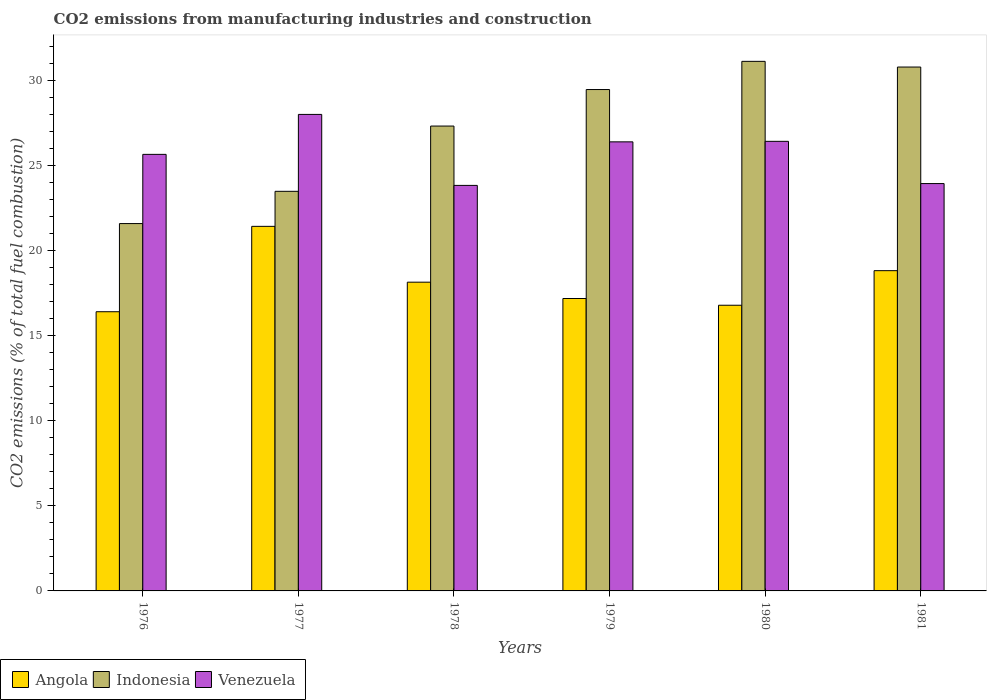How many different coloured bars are there?
Keep it short and to the point. 3. How many groups of bars are there?
Your answer should be compact. 6. Are the number of bars on each tick of the X-axis equal?
Your answer should be compact. Yes. What is the amount of CO2 emitted in Angola in 1980?
Provide a short and direct response. 16.79. Across all years, what is the maximum amount of CO2 emitted in Venezuela?
Your answer should be compact. 28.01. Across all years, what is the minimum amount of CO2 emitted in Venezuela?
Keep it short and to the point. 23.84. In which year was the amount of CO2 emitted in Indonesia maximum?
Ensure brevity in your answer.  1980. In which year was the amount of CO2 emitted in Indonesia minimum?
Ensure brevity in your answer.  1976. What is the total amount of CO2 emitted in Angola in the graph?
Ensure brevity in your answer.  108.79. What is the difference between the amount of CO2 emitted in Angola in 1977 and that in 1979?
Keep it short and to the point. 4.24. What is the difference between the amount of CO2 emitted in Angola in 1977 and the amount of CO2 emitted in Indonesia in 1980?
Provide a succinct answer. -9.7. What is the average amount of CO2 emitted in Angola per year?
Your answer should be compact. 18.13. In the year 1980, what is the difference between the amount of CO2 emitted in Indonesia and amount of CO2 emitted in Venezuela?
Ensure brevity in your answer.  4.7. What is the ratio of the amount of CO2 emitted in Angola in 1977 to that in 1981?
Your answer should be compact. 1.14. Is the amount of CO2 emitted in Venezuela in 1976 less than that in 1978?
Offer a very short reply. No. What is the difference between the highest and the second highest amount of CO2 emitted in Venezuela?
Keep it short and to the point. 1.58. What is the difference between the highest and the lowest amount of CO2 emitted in Venezuela?
Ensure brevity in your answer.  4.17. In how many years, is the amount of CO2 emitted in Venezuela greater than the average amount of CO2 emitted in Venezuela taken over all years?
Your answer should be compact. 3. What does the 3rd bar from the right in 1981 represents?
Your response must be concise. Angola. Are all the bars in the graph horizontal?
Your answer should be very brief. No. What is the difference between two consecutive major ticks on the Y-axis?
Keep it short and to the point. 5. Are the values on the major ticks of Y-axis written in scientific E-notation?
Your answer should be very brief. No. Does the graph contain grids?
Ensure brevity in your answer.  No. Where does the legend appear in the graph?
Ensure brevity in your answer.  Bottom left. What is the title of the graph?
Give a very brief answer. CO2 emissions from manufacturing industries and construction. What is the label or title of the Y-axis?
Keep it short and to the point. CO2 emissions (% of total fuel combustion). What is the CO2 emissions (% of total fuel combustion) in Angola in 1976?
Make the answer very short. 16.41. What is the CO2 emissions (% of total fuel combustion) of Indonesia in 1976?
Your answer should be very brief. 21.59. What is the CO2 emissions (% of total fuel combustion) of Venezuela in 1976?
Offer a terse response. 25.66. What is the CO2 emissions (% of total fuel combustion) in Angola in 1977?
Provide a succinct answer. 21.43. What is the CO2 emissions (% of total fuel combustion) of Indonesia in 1977?
Make the answer very short. 23.49. What is the CO2 emissions (% of total fuel combustion) in Venezuela in 1977?
Give a very brief answer. 28.01. What is the CO2 emissions (% of total fuel combustion) of Angola in 1978?
Offer a very short reply. 18.15. What is the CO2 emissions (% of total fuel combustion) of Indonesia in 1978?
Ensure brevity in your answer.  27.32. What is the CO2 emissions (% of total fuel combustion) in Venezuela in 1978?
Your answer should be very brief. 23.84. What is the CO2 emissions (% of total fuel combustion) in Angola in 1979?
Your answer should be very brief. 17.19. What is the CO2 emissions (% of total fuel combustion) of Indonesia in 1979?
Give a very brief answer. 29.47. What is the CO2 emissions (% of total fuel combustion) of Venezuela in 1979?
Give a very brief answer. 26.4. What is the CO2 emissions (% of total fuel combustion) of Angola in 1980?
Your answer should be very brief. 16.79. What is the CO2 emissions (% of total fuel combustion) in Indonesia in 1980?
Provide a short and direct response. 31.13. What is the CO2 emissions (% of total fuel combustion) of Venezuela in 1980?
Your response must be concise. 26.43. What is the CO2 emissions (% of total fuel combustion) of Angola in 1981?
Your answer should be compact. 18.82. What is the CO2 emissions (% of total fuel combustion) of Indonesia in 1981?
Ensure brevity in your answer.  30.79. What is the CO2 emissions (% of total fuel combustion) in Venezuela in 1981?
Your response must be concise. 23.94. Across all years, what is the maximum CO2 emissions (% of total fuel combustion) in Angola?
Give a very brief answer. 21.43. Across all years, what is the maximum CO2 emissions (% of total fuel combustion) in Indonesia?
Ensure brevity in your answer.  31.13. Across all years, what is the maximum CO2 emissions (% of total fuel combustion) of Venezuela?
Your answer should be very brief. 28.01. Across all years, what is the minimum CO2 emissions (% of total fuel combustion) of Angola?
Keep it short and to the point. 16.41. Across all years, what is the minimum CO2 emissions (% of total fuel combustion) in Indonesia?
Offer a terse response. 21.59. Across all years, what is the minimum CO2 emissions (% of total fuel combustion) of Venezuela?
Offer a very short reply. 23.84. What is the total CO2 emissions (% of total fuel combustion) of Angola in the graph?
Provide a short and direct response. 108.79. What is the total CO2 emissions (% of total fuel combustion) in Indonesia in the graph?
Your answer should be compact. 163.79. What is the total CO2 emissions (% of total fuel combustion) in Venezuela in the graph?
Keep it short and to the point. 154.27. What is the difference between the CO2 emissions (% of total fuel combustion) in Angola in 1976 and that in 1977?
Provide a succinct answer. -5.02. What is the difference between the CO2 emissions (% of total fuel combustion) in Indonesia in 1976 and that in 1977?
Provide a succinct answer. -1.9. What is the difference between the CO2 emissions (% of total fuel combustion) of Venezuela in 1976 and that in 1977?
Your answer should be compact. -2.35. What is the difference between the CO2 emissions (% of total fuel combustion) of Angola in 1976 and that in 1978?
Provide a succinct answer. -1.74. What is the difference between the CO2 emissions (% of total fuel combustion) in Indonesia in 1976 and that in 1978?
Provide a short and direct response. -5.73. What is the difference between the CO2 emissions (% of total fuel combustion) in Venezuela in 1976 and that in 1978?
Provide a short and direct response. 1.82. What is the difference between the CO2 emissions (% of total fuel combustion) in Angola in 1976 and that in 1979?
Provide a short and direct response. -0.78. What is the difference between the CO2 emissions (% of total fuel combustion) of Indonesia in 1976 and that in 1979?
Keep it short and to the point. -7.88. What is the difference between the CO2 emissions (% of total fuel combustion) of Venezuela in 1976 and that in 1979?
Your response must be concise. -0.74. What is the difference between the CO2 emissions (% of total fuel combustion) in Angola in 1976 and that in 1980?
Your response must be concise. -0.38. What is the difference between the CO2 emissions (% of total fuel combustion) in Indonesia in 1976 and that in 1980?
Give a very brief answer. -9.53. What is the difference between the CO2 emissions (% of total fuel combustion) in Venezuela in 1976 and that in 1980?
Keep it short and to the point. -0.77. What is the difference between the CO2 emissions (% of total fuel combustion) in Angola in 1976 and that in 1981?
Give a very brief answer. -2.41. What is the difference between the CO2 emissions (% of total fuel combustion) in Indonesia in 1976 and that in 1981?
Your response must be concise. -9.2. What is the difference between the CO2 emissions (% of total fuel combustion) in Venezuela in 1976 and that in 1981?
Keep it short and to the point. 1.72. What is the difference between the CO2 emissions (% of total fuel combustion) of Angola in 1977 and that in 1978?
Your answer should be very brief. 3.28. What is the difference between the CO2 emissions (% of total fuel combustion) in Indonesia in 1977 and that in 1978?
Offer a terse response. -3.84. What is the difference between the CO2 emissions (% of total fuel combustion) in Venezuela in 1977 and that in 1978?
Offer a terse response. 4.17. What is the difference between the CO2 emissions (% of total fuel combustion) of Angola in 1977 and that in 1979?
Your response must be concise. 4.24. What is the difference between the CO2 emissions (% of total fuel combustion) in Indonesia in 1977 and that in 1979?
Keep it short and to the point. -5.98. What is the difference between the CO2 emissions (% of total fuel combustion) in Venezuela in 1977 and that in 1979?
Offer a terse response. 1.61. What is the difference between the CO2 emissions (% of total fuel combustion) of Angola in 1977 and that in 1980?
Ensure brevity in your answer.  4.64. What is the difference between the CO2 emissions (% of total fuel combustion) in Indonesia in 1977 and that in 1980?
Provide a succinct answer. -7.64. What is the difference between the CO2 emissions (% of total fuel combustion) of Venezuela in 1977 and that in 1980?
Provide a succinct answer. 1.58. What is the difference between the CO2 emissions (% of total fuel combustion) in Angola in 1977 and that in 1981?
Your response must be concise. 2.6. What is the difference between the CO2 emissions (% of total fuel combustion) of Indonesia in 1977 and that in 1981?
Provide a short and direct response. -7.3. What is the difference between the CO2 emissions (% of total fuel combustion) in Venezuela in 1977 and that in 1981?
Provide a short and direct response. 4.06. What is the difference between the CO2 emissions (% of total fuel combustion) in Angola in 1978 and that in 1979?
Give a very brief answer. 0.96. What is the difference between the CO2 emissions (% of total fuel combustion) of Indonesia in 1978 and that in 1979?
Offer a very short reply. -2.15. What is the difference between the CO2 emissions (% of total fuel combustion) of Venezuela in 1978 and that in 1979?
Make the answer very short. -2.56. What is the difference between the CO2 emissions (% of total fuel combustion) of Angola in 1978 and that in 1980?
Ensure brevity in your answer.  1.36. What is the difference between the CO2 emissions (% of total fuel combustion) of Indonesia in 1978 and that in 1980?
Keep it short and to the point. -3.8. What is the difference between the CO2 emissions (% of total fuel combustion) in Venezuela in 1978 and that in 1980?
Keep it short and to the point. -2.59. What is the difference between the CO2 emissions (% of total fuel combustion) of Angola in 1978 and that in 1981?
Ensure brevity in your answer.  -0.68. What is the difference between the CO2 emissions (% of total fuel combustion) in Indonesia in 1978 and that in 1981?
Your answer should be very brief. -3.47. What is the difference between the CO2 emissions (% of total fuel combustion) in Venezuela in 1978 and that in 1981?
Keep it short and to the point. -0.11. What is the difference between the CO2 emissions (% of total fuel combustion) in Angola in 1979 and that in 1980?
Provide a short and direct response. 0.4. What is the difference between the CO2 emissions (% of total fuel combustion) of Indonesia in 1979 and that in 1980?
Make the answer very short. -1.66. What is the difference between the CO2 emissions (% of total fuel combustion) of Venezuela in 1979 and that in 1980?
Offer a terse response. -0.03. What is the difference between the CO2 emissions (% of total fuel combustion) in Angola in 1979 and that in 1981?
Offer a very short reply. -1.64. What is the difference between the CO2 emissions (% of total fuel combustion) in Indonesia in 1979 and that in 1981?
Your response must be concise. -1.32. What is the difference between the CO2 emissions (% of total fuel combustion) in Venezuela in 1979 and that in 1981?
Your response must be concise. 2.45. What is the difference between the CO2 emissions (% of total fuel combustion) of Angola in 1980 and that in 1981?
Your answer should be very brief. -2.03. What is the difference between the CO2 emissions (% of total fuel combustion) in Indonesia in 1980 and that in 1981?
Keep it short and to the point. 0.33. What is the difference between the CO2 emissions (% of total fuel combustion) of Venezuela in 1980 and that in 1981?
Offer a very short reply. 2.48. What is the difference between the CO2 emissions (% of total fuel combustion) in Angola in 1976 and the CO2 emissions (% of total fuel combustion) in Indonesia in 1977?
Ensure brevity in your answer.  -7.08. What is the difference between the CO2 emissions (% of total fuel combustion) in Angola in 1976 and the CO2 emissions (% of total fuel combustion) in Venezuela in 1977?
Ensure brevity in your answer.  -11.6. What is the difference between the CO2 emissions (% of total fuel combustion) of Indonesia in 1976 and the CO2 emissions (% of total fuel combustion) of Venezuela in 1977?
Provide a short and direct response. -6.42. What is the difference between the CO2 emissions (% of total fuel combustion) in Angola in 1976 and the CO2 emissions (% of total fuel combustion) in Indonesia in 1978?
Make the answer very short. -10.91. What is the difference between the CO2 emissions (% of total fuel combustion) of Angola in 1976 and the CO2 emissions (% of total fuel combustion) of Venezuela in 1978?
Offer a terse response. -7.43. What is the difference between the CO2 emissions (% of total fuel combustion) in Indonesia in 1976 and the CO2 emissions (% of total fuel combustion) in Venezuela in 1978?
Your response must be concise. -2.24. What is the difference between the CO2 emissions (% of total fuel combustion) in Angola in 1976 and the CO2 emissions (% of total fuel combustion) in Indonesia in 1979?
Make the answer very short. -13.06. What is the difference between the CO2 emissions (% of total fuel combustion) in Angola in 1976 and the CO2 emissions (% of total fuel combustion) in Venezuela in 1979?
Offer a very short reply. -9.99. What is the difference between the CO2 emissions (% of total fuel combustion) in Indonesia in 1976 and the CO2 emissions (% of total fuel combustion) in Venezuela in 1979?
Your response must be concise. -4.8. What is the difference between the CO2 emissions (% of total fuel combustion) of Angola in 1976 and the CO2 emissions (% of total fuel combustion) of Indonesia in 1980?
Offer a very short reply. -14.72. What is the difference between the CO2 emissions (% of total fuel combustion) in Angola in 1976 and the CO2 emissions (% of total fuel combustion) in Venezuela in 1980?
Your answer should be very brief. -10.02. What is the difference between the CO2 emissions (% of total fuel combustion) of Indonesia in 1976 and the CO2 emissions (% of total fuel combustion) of Venezuela in 1980?
Offer a terse response. -4.83. What is the difference between the CO2 emissions (% of total fuel combustion) of Angola in 1976 and the CO2 emissions (% of total fuel combustion) of Indonesia in 1981?
Provide a succinct answer. -14.38. What is the difference between the CO2 emissions (% of total fuel combustion) in Angola in 1976 and the CO2 emissions (% of total fuel combustion) in Venezuela in 1981?
Provide a short and direct response. -7.53. What is the difference between the CO2 emissions (% of total fuel combustion) in Indonesia in 1976 and the CO2 emissions (% of total fuel combustion) in Venezuela in 1981?
Provide a short and direct response. -2.35. What is the difference between the CO2 emissions (% of total fuel combustion) in Angola in 1977 and the CO2 emissions (% of total fuel combustion) in Indonesia in 1978?
Provide a short and direct response. -5.89. What is the difference between the CO2 emissions (% of total fuel combustion) of Angola in 1977 and the CO2 emissions (% of total fuel combustion) of Venezuela in 1978?
Provide a short and direct response. -2.41. What is the difference between the CO2 emissions (% of total fuel combustion) in Indonesia in 1977 and the CO2 emissions (% of total fuel combustion) in Venezuela in 1978?
Offer a terse response. -0.35. What is the difference between the CO2 emissions (% of total fuel combustion) of Angola in 1977 and the CO2 emissions (% of total fuel combustion) of Indonesia in 1979?
Offer a terse response. -8.04. What is the difference between the CO2 emissions (% of total fuel combustion) in Angola in 1977 and the CO2 emissions (% of total fuel combustion) in Venezuela in 1979?
Offer a terse response. -4.97. What is the difference between the CO2 emissions (% of total fuel combustion) of Indonesia in 1977 and the CO2 emissions (% of total fuel combustion) of Venezuela in 1979?
Your response must be concise. -2.91. What is the difference between the CO2 emissions (% of total fuel combustion) of Angola in 1977 and the CO2 emissions (% of total fuel combustion) of Indonesia in 1980?
Provide a succinct answer. -9.7. What is the difference between the CO2 emissions (% of total fuel combustion) in Angola in 1977 and the CO2 emissions (% of total fuel combustion) in Venezuela in 1980?
Ensure brevity in your answer.  -5. What is the difference between the CO2 emissions (% of total fuel combustion) of Indonesia in 1977 and the CO2 emissions (% of total fuel combustion) of Venezuela in 1980?
Offer a terse response. -2.94. What is the difference between the CO2 emissions (% of total fuel combustion) in Angola in 1977 and the CO2 emissions (% of total fuel combustion) in Indonesia in 1981?
Provide a short and direct response. -9.36. What is the difference between the CO2 emissions (% of total fuel combustion) in Angola in 1977 and the CO2 emissions (% of total fuel combustion) in Venezuela in 1981?
Ensure brevity in your answer.  -2.51. What is the difference between the CO2 emissions (% of total fuel combustion) in Indonesia in 1977 and the CO2 emissions (% of total fuel combustion) in Venezuela in 1981?
Give a very brief answer. -0.46. What is the difference between the CO2 emissions (% of total fuel combustion) in Angola in 1978 and the CO2 emissions (% of total fuel combustion) in Indonesia in 1979?
Your answer should be compact. -11.32. What is the difference between the CO2 emissions (% of total fuel combustion) of Angola in 1978 and the CO2 emissions (% of total fuel combustion) of Venezuela in 1979?
Make the answer very short. -8.25. What is the difference between the CO2 emissions (% of total fuel combustion) of Indonesia in 1978 and the CO2 emissions (% of total fuel combustion) of Venezuela in 1979?
Your response must be concise. 0.93. What is the difference between the CO2 emissions (% of total fuel combustion) in Angola in 1978 and the CO2 emissions (% of total fuel combustion) in Indonesia in 1980?
Your response must be concise. -12.98. What is the difference between the CO2 emissions (% of total fuel combustion) in Angola in 1978 and the CO2 emissions (% of total fuel combustion) in Venezuela in 1980?
Ensure brevity in your answer.  -8.28. What is the difference between the CO2 emissions (% of total fuel combustion) in Indonesia in 1978 and the CO2 emissions (% of total fuel combustion) in Venezuela in 1980?
Offer a terse response. 0.9. What is the difference between the CO2 emissions (% of total fuel combustion) in Angola in 1978 and the CO2 emissions (% of total fuel combustion) in Indonesia in 1981?
Make the answer very short. -12.65. What is the difference between the CO2 emissions (% of total fuel combustion) of Angola in 1978 and the CO2 emissions (% of total fuel combustion) of Venezuela in 1981?
Ensure brevity in your answer.  -5.8. What is the difference between the CO2 emissions (% of total fuel combustion) of Indonesia in 1978 and the CO2 emissions (% of total fuel combustion) of Venezuela in 1981?
Your response must be concise. 3.38. What is the difference between the CO2 emissions (% of total fuel combustion) in Angola in 1979 and the CO2 emissions (% of total fuel combustion) in Indonesia in 1980?
Provide a short and direct response. -13.94. What is the difference between the CO2 emissions (% of total fuel combustion) in Angola in 1979 and the CO2 emissions (% of total fuel combustion) in Venezuela in 1980?
Provide a succinct answer. -9.24. What is the difference between the CO2 emissions (% of total fuel combustion) in Indonesia in 1979 and the CO2 emissions (% of total fuel combustion) in Venezuela in 1980?
Make the answer very short. 3.04. What is the difference between the CO2 emissions (% of total fuel combustion) of Angola in 1979 and the CO2 emissions (% of total fuel combustion) of Indonesia in 1981?
Your answer should be compact. -13.6. What is the difference between the CO2 emissions (% of total fuel combustion) of Angola in 1979 and the CO2 emissions (% of total fuel combustion) of Venezuela in 1981?
Provide a succinct answer. -6.76. What is the difference between the CO2 emissions (% of total fuel combustion) of Indonesia in 1979 and the CO2 emissions (% of total fuel combustion) of Venezuela in 1981?
Offer a very short reply. 5.53. What is the difference between the CO2 emissions (% of total fuel combustion) of Angola in 1980 and the CO2 emissions (% of total fuel combustion) of Indonesia in 1981?
Give a very brief answer. -14. What is the difference between the CO2 emissions (% of total fuel combustion) of Angola in 1980 and the CO2 emissions (% of total fuel combustion) of Venezuela in 1981?
Your answer should be very brief. -7.15. What is the difference between the CO2 emissions (% of total fuel combustion) in Indonesia in 1980 and the CO2 emissions (% of total fuel combustion) in Venezuela in 1981?
Provide a short and direct response. 7.18. What is the average CO2 emissions (% of total fuel combustion) in Angola per year?
Give a very brief answer. 18.13. What is the average CO2 emissions (% of total fuel combustion) of Indonesia per year?
Offer a very short reply. 27.3. What is the average CO2 emissions (% of total fuel combustion) in Venezuela per year?
Make the answer very short. 25.71. In the year 1976, what is the difference between the CO2 emissions (% of total fuel combustion) in Angola and CO2 emissions (% of total fuel combustion) in Indonesia?
Your answer should be very brief. -5.18. In the year 1976, what is the difference between the CO2 emissions (% of total fuel combustion) in Angola and CO2 emissions (% of total fuel combustion) in Venezuela?
Ensure brevity in your answer.  -9.25. In the year 1976, what is the difference between the CO2 emissions (% of total fuel combustion) of Indonesia and CO2 emissions (% of total fuel combustion) of Venezuela?
Your answer should be compact. -4.07. In the year 1977, what is the difference between the CO2 emissions (% of total fuel combustion) in Angola and CO2 emissions (% of total fuel combustion) in Indonesia?
Your answer should be compact. -2.06. In the year 1977, what is the difference between the CO2 emissions (% of total fuel combustion) of Angola and CO2 emissions (% of total fuel combustion) of Venezuela?
Make the answer very short. -6.58. In the year 1977, what is the difference between the CO2 emissions (% of total fuel combustion) in Indonesia and CO2 emissions (% of total fuel combustion) in Venezuela?
Your response must be concise. -4.52. In the year 1978, what is the difference between the CO2 emissions (% of total fuel combustion) of Angola and CO2 emissions (% of total fuel combustion) of Indonesia?
Offer a very short reply. -9.18. In the year 1978, what is the difference between the CO2 emissions (% of total fuel combustion) in Angola and CO2 emissions (% of total fuel combustion) in Venezuela?
Ensure brevity in your answer.  -5.69. In the year 1978, what is the difference between the CO2 emissions (% of total fuel combustion) of Indonesia and CO2 emissions (% of total fuel combustion) of Venezuela?
Offer a terse response. 3.49. In the year 1979, what is the difference between the CO2 emissions (% of total fuel combustion) in Angola and CO2 emissions (% of total fuel combustion) in Indonesia?
Make the answer very short. -12.28. In the year 1979, what is the difference between the CO2 emissions (% of total fuel combustion) of Angola and CO2 emissions (% of total fuel combustion) of Venezuela?
Ensure brevity in your answer.  -9.21. In the year 1979, what is the difference between the CO2 emissions (% of total fuel combustion) of Indonesia and CO2 emissions (% of total fuel combustion) of Venezuela?
Your answer should be very brief. 3.07. In the year 1980, what is the difference between the CO2 emissions (% of total fuel combustion) of Angola and CO2 emissions (% of total fuel combustion) of Indonesia?
Give a very brief answer. -14.34. In the year 1980, what is the difference between the CO2 emissions (% of total fuel combustion) in Angola and CO2 emissions (% of total fuel combustion) in Venezuela?
Provide a succinct answer. -9.63. In the year 1980, what is the difference between the CO2 emissions (% of total fuel combustion) in Indonesia and CO2 emissions (% of total fuel combustion) in Venezuela?
Ensure brevity in your answer.  4.7. In the year 1981, what is the difference between the CO2 emissions (% of total fuel combustion) in Angola and CO2 emissions (% of total fuel combustion) in Indonesia?
Your response must be concise. -11.97. In the year 1981, what is the difference between the CO2 emissions (% of total fuel combustion) in Angola and CO2 emissions (% of total fuel combustion) in Venezuela?
Ensure brevity in your answer.  -5.12. In the year 1981, what is the difference between the CO2 emissions (% of total fuel combustion) of Indonesia and CO2 emissions (% of total fuel combustion) of Venezuela?
Ensure brevity in your answer.  6.85. What is the ratio of the CO2 emissions (% of total fuel combustion) in Angola in 1976 to that in 1977?
Offer a terse response. 0.77. What is the ratio of the CO2 emissions (% of total fuel combustion) in Indonesia in 1976 to that in 1977?
Give a very brief answer. 0.92. What is the ratio of the CO2 emissions (% of total fuel combustion) of Venezuela in 1976 to that in 1977?
Ensure brevity in your answer.  0.92. What is the ratio of the CO2 emissions (% of total fuel combustion) in Angola in 1976 to that in 1978?
Offer a very short reply. 0.9. What is the ratio of the CO2 emissions (% of total fuel combustion) in Indonesia in 1976 to that in 1978?
Give a very brief answer. 0.79. What is the ratio of the CO2 emissions (% of total fuel combustion) in Venezuela in 1976 to that in 1978?
Make the answer very short. 1.08. What is the ratio of the CO2 emissions (% of total fuel combustion) in Angola in 1976 to that in 1979?
Your answer should be very brief. 0.95. What is the ratio of the CO2 emissions (% of total fuel combustion) in Indonesia in 1976 to that in 1979?
Keep it short and to the point. 0.73. What is the ratio of the CO2 emissions (% of total fuel combustion) of Venezuela in 1976 to that in 1979?
Offer a terse response. 0.97. What is the ratio of the CO2 emissions (% of total fuel combustion) in Angola in 1976 to that in 1980?
Keep it short and to the point. 0.98. What is the ratio of the CO2 emissions (% of total fuel combustion) of Indonesia in 1976 to that in 1980?
Offer a very short reply. 0.69. What is the ratio of the CO2 emissions (% of total fuel combustion) of Venezuela in 1976 to that in 1980?
Keep it short and to the point. 0.97. What is the ratio of the CO2 emissions (% of total fuel combustion) in Angola in 1976 to that in 1981?
Provide a short and direct response. 0.87. What is the ratio of the CO2 emissions (% of total fuel combustion) of Indonesia in 1976 to that in 1981?
Make the answer very short. 0.7. What is the ratio of the CO2 emissions (% of total fuel combustion) of Venezuela in 1976 to that in 1981?
Your answer should be compact. 1.07. What is the ratio of the CO2 emissions (% of total fuel combustion) of Angola in 1977 to that in 1978?
Ensure brevity in your answer.  1.18. What is the ratio of the CO2 emissions (% of total fuel combustion) in Indonesia in 1977 to that in 1978?
Provide a short and direct response. 0.86. What is the ratio of the CO2 emissions (% of total fuel combustion) of Venezuela in 1977 to that in 1978?
Your answer should be compact. 1.18. What is the ratio of the CO2 emissions (% of total fuel combustion) of Angola in 1977 to that in 1979?
Provide a short and direct response. 1.25. What is the ratio of the CO2 emissions (% of total fuel combustion) of Indonesia in 1977 to that in 1979?
Make the answer very short. 0.8. What is the ratio of the CO2 emissions (% of total fuel combustion) of Venezuela in 1977 to that in 1979?
Keep it short and to the point. 1.06. What is the ratio of the CO2 emissions (% of total fuel combustion) in Angola in 1977 to that in 1980?
Make the answer very short. 1.28. What is the ratio of the CO2 emissions (% of total fuel combustion) of Indonesia in 1977 to that in 1980?
Make the answer very short. 0.75. What is the ratio of the CO2 emissions (% of total fuel combustion) in Venezuela in 1977 to that in 1980?
Keep it short and to the point. 1.06. What is the ratio of the CO2 emissions (% of total fuel combustion) of Angola in 1977 to that in 1981?
Provide a succinct answer. 1.14. What is the ratio of the CO2 emissions (% of total fuel combustion) in Indonesia in 1977 to that in 1981?
Offer a very short reply. 0.76. What is the ratio of the CO2 emissions (% of total fuel combustion) of Venezuela in 1977 to that in 1981?
Make the answer very short. 1.17. What is the ratio of the CO2 emissions (% of total fuel combustion) in Angola in 1978 to that in 1979?
Your answer should be compact. 1.06. What is the ratio of the CO2 emissions (% of total fuel combustion) in Indonesia in 1978 to that in 1979?
Your response must be concise. 0.93. What is the ratio of the CO2 emissions (% of total fuel combustion) of Venezuela in 1978 to that in 1979?
Make the answer very short. 0.9. What is the ratio of the CO2 emissions (% of total fuel combustion) of Angola in 1978 to that in 1980?
Provide a short and direct response. 1.08. What is the ratio of the CO2 emissions (% of total fuel combustion) of Indonesia in 1978 to that in 1980?
Make the answer very short. 0.88. What is the ratio of the CO2 emissions (% of total fuel combustion) in Venezuela in 1978 to that in 1980?
Your response must be concise. 0.9. What is the ratio of the CO2 emissions (% of total fuel combustion) of Indonesia in 1978 to that in 1981?
Offer a very short reply. 0.89. What is the ratio of the CO2 emissions (% of total fuel combustion) in Venezuela in 1978 to that in 1981?
Your answer should be compact. 1. What is the ratio of the CO2 emissions (% of total fuel combustion) of Angola in 1979 to that in 1980?
Provide a succinct answer. 1.02. What is the ratio of the CO2 emissions (% of total fuel combustion) of Indonesia in 1979 to that in 1980?
Make the answer very short. 0.95. What is the ratio of the CO2 emissions (% of total fuel combustion) in Angola in 1979 to that in 1981?
Make the answer very short. 0.91. What is the ratio of the CO2 emissions (% of total fuel combustion) in Indonesia in 1979 to that in 1981?
Your response must be concise. 0.96. What is the ratio of the CO2 emissions (% of total fuel combustion) of Venezuela in 1979 to that in 1981?
Your answer should be very brief. 1.1. What is the ratio of the CO2 emissions (% of total fuel combustion) in Angola in 1980 to that in 1981?
Your response must be concise. 0.89. What is the ratio of the CO2 emissions (% of total fuel combustion) in Indonesia in 1980 to that in 1981?
Offer a very short reply. 1.01. What is the ratio of the CO2 emissions (% of total fuel combustion) in Venezuela in 1980 to that in 1981?
Provide a succinct answer. 1.1. What is the difference between the highest and the second highest CO2 emissions (% of total fuel combustion) in Angola?
Your answer should be very brief. 2.6. What is the difference between the highest and the second highest CO2 emissions (% of total fuel combustion) of Indonesia?
Keep it short and to the point. 0.33. What is the difference between the highest and the second highest CO2 emissions (% of total fuel combustion) in Venezuela?
Offer a very short reply. 1.58. What is the difference between the highest and the lowest CO2 emissions (% of total fuel combustion) of Angola?
Provide a succinct answer. 5.02. What is the difference between the highest and the lowest CO2 emissions (% of total fuel combustion) of Indonesia?
Give a very brief answer. 9.53. What is the difference between the highest and the lowest CO2 emissions (% of total fuel combustion) of Venezuela?
Ensure brevity in your answer.  4.17. 